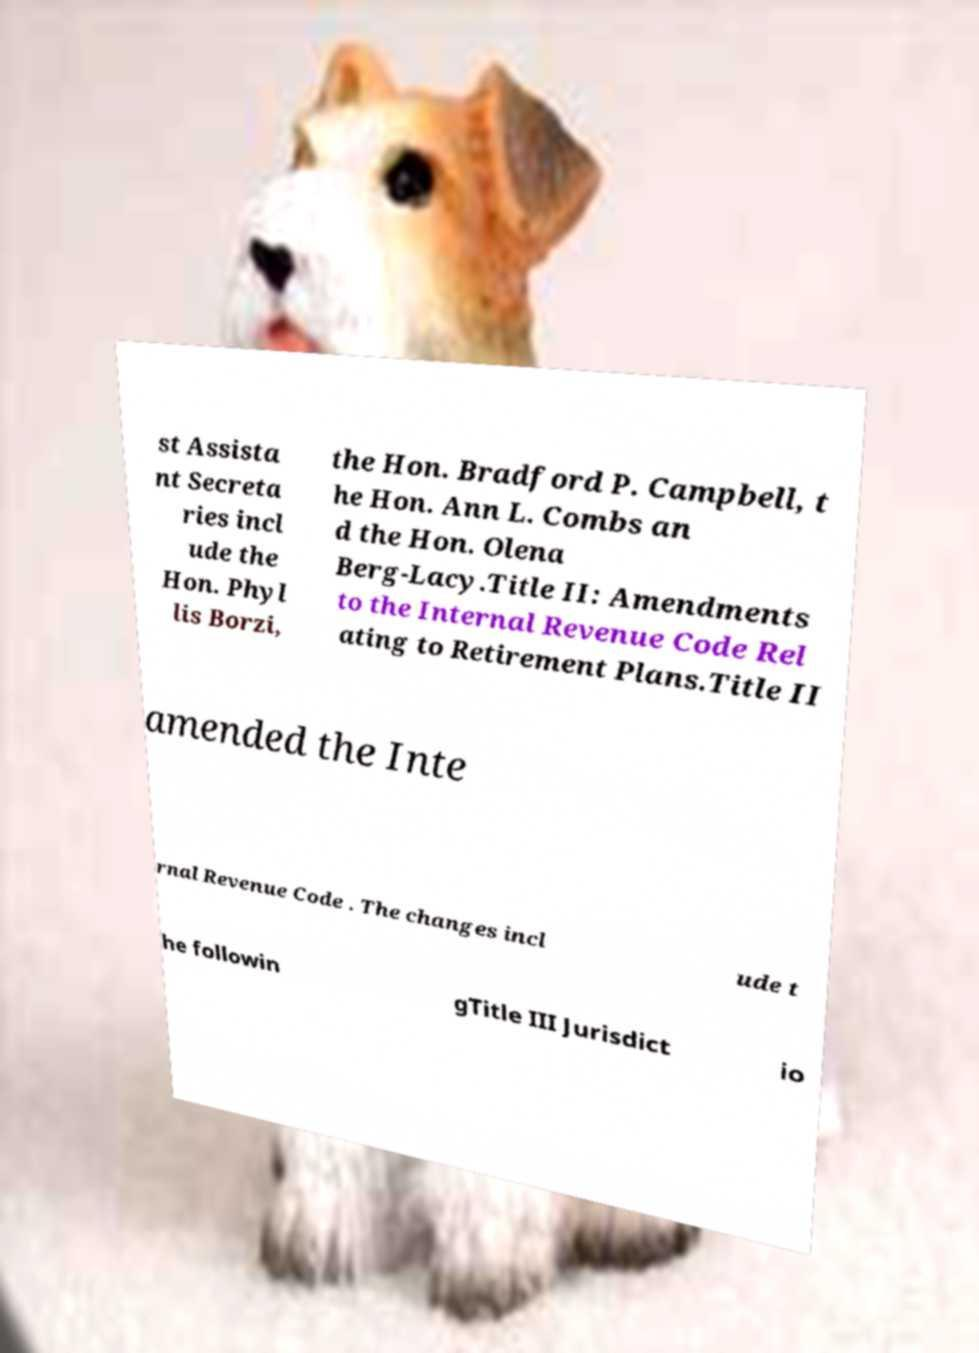For documentation purposes, I need the text within this image transcribed. Could you provide that? st Assista nt Secreta ries incl ude the Hon. Phyl lis Borzi, the Hon. Bradford P. Campbell, t he Hon. Ann L. Combs an d the Hon. Olena Berg-Lacy.Title II: Amendments to the Internal Revenue Code Rel ating to Retirement Plans.Title II amended the Inte rnal Revenue Code . The changes incl ude t he followin gTitle III Jurisdict io 